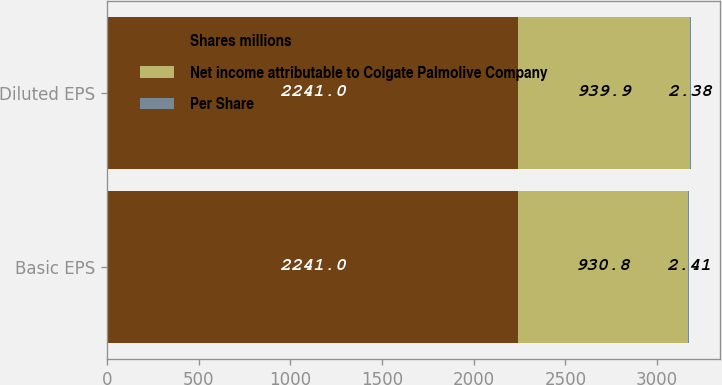Convert chart to OTSL. <chart><loc_0><loc_0><loc_500><loc_500><stacked_bar_chart><ecel><fcel>Basic EPS<fcel>Diluted EPS<nl><fcel>Shares millions<fcel>2241<fcel>2241<nl><fcel>Net income attributable to Colgate Palmolive Company<fcel>930.8<fcel>939.9<nl><fcel>Per Share<fcel>2.41<fcel>2.38<nl></chart> 